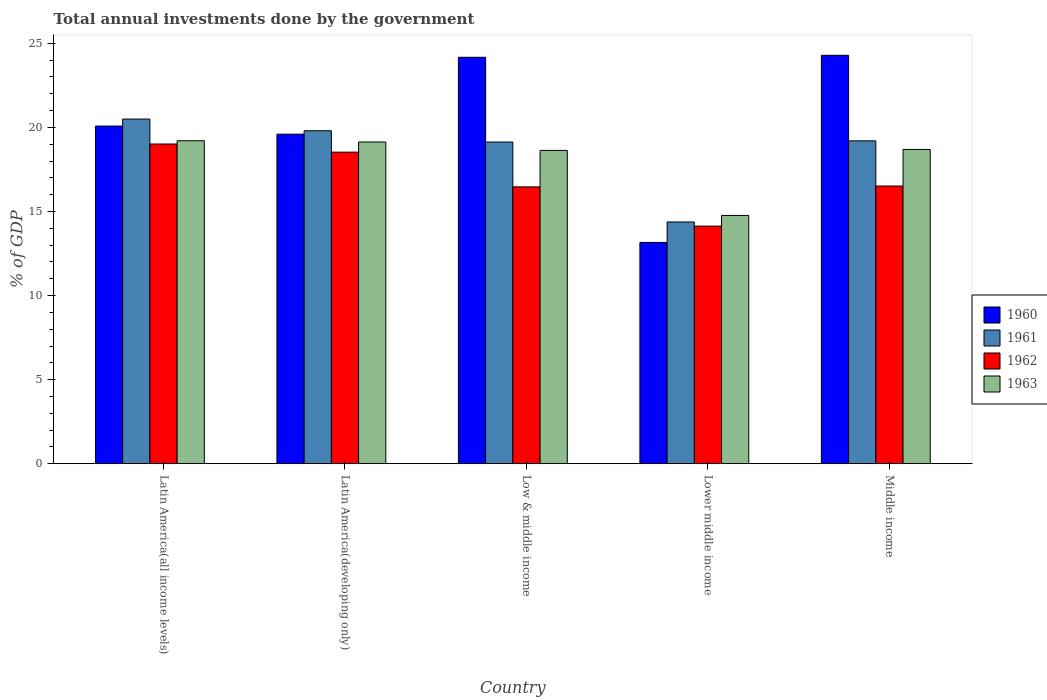Are the number of bars on each tick of the X-axis equal?
Provide a short and direct response. Yes. What is the label of the 2nd group of bars from the left?
Keep it short and to the point. Latin America(developing only). In how many cases, is the number of bars for a given country not equal to the number of legend labels?
Offer a terse response. 0. What is the total annual investments done by the government in 1961 in Lower middle income?
Ensure brevity in your answer.  14.37. Across all countries, what is the maximum total annual investments done by the government in 1962?
Offer a terse response. 19.01. Across all countries, what is the minimum total annual investments done by the government in 1961?
Offer a very short reply. 14.37. In which country was the total annual investments done by the government in 1962 maximum?
Provide a succinct answer. Latin America(all income levels). In which country was the total annual investments done by the government in 1961 minimum?
Provide a succinct answer. Lower middle income. What is the total total annual investments done by the government in 1961 in the graph?
Keep it short and to the point. 92.99. What is the difference between the total annual investments done by the government in 1962 in Lower middle income and that in Middle income?
Ensure brevity in your answer.  -2.38. What is the difference between the total annual investments done by the government in 1962 in Low & middle income and the total annual investments done by the government in 1963 in Middle income?
Your response must be concise. -2.22. What is the average total annual investments done by the government in 1963 per country?
Offer a terse response. 18.08. What is the difference between the total annual investments done by the government of/in 1961 and total annual investments done by the government of/in 1960 in Latin America(all income levels)?
Keep it short and to the point. 0.42. What is the ratio of the total annual investments done by the government in 1963 in Latin America(all income levels) to that in Middle income?
Give a very brief answer. 1.03. Is the total annual investments done by the government in 1963 in Low & middle income less than that in Middle income?
Make the answer very short. Yes. Is the difference between the total annual investments done by the government in 1961 in Latin America(all income levels) and Low & middle income greater than the difference between the total annual investments done by the government in 1960 in Latin America(all income levels) and Low & middle income?
Your response must be concise. Yes. What is the difference between the highest and the second highest total annual investments done by the government in 1961?
Your answer should be very brief. -0.6. What is the difference between the highest and the lowest total annual investments done by the government in 1962?
Ensure brevity in your answer.  4.88. In how many countries, is the total annual investments done by the government in 1961 greater than the average total annual investments done by the government in 1961 taken over all countries?
Your response must be concise. 4. Is the sum of the total annual investments done by the government in 1960 in Low & middle income and Lower middle income greater than the maximum total annual investments done by the government in 1963 across all countries?
Provide a short and direct response. Yes. Is it the case that in every country, the sum of the total annual investments done by the government in 1963 and total annual investments done by the government in 1960 is greater than the sum of total annual investments done by the government in 1961 and total annual investments done by the government in 1962?
Your answer should be compact. No. What does the 3rd bar from the left in Latin America(developing only) represents?
Provide a short and direct response. 1962. Is it the case that in every country, the sum of the total annual investments done by the government in 1963 and total annual investments done by the government in 1961 is greater than the total annual investments done by the government in 1962?
Offer a terse response. Yes. How many countries are there in the graph?
Make the answer very short. 5. Where does the legend appear in the graph?
Offer a terse response. Center right. How many legend labels are there?
Make the answer very short. 4. How are the legend labels stacked?
Keep it short and to the point. Vertical. What is the title of the graph?
Provide a succinct answer. Total annual investments done by the government. What is the label or title of the X-axis?
Ensure brevity in your answer.  Country. What is the label or title of the Y-axis?
Ensure brevity in your answer.  % of GDP. What is the % of GDP in 1960 in Latin America(all income levels)?
Make the answer very short. 20.08. What is the % of GDP of 1961 in Latin America(all income levels)?
Offer a very short reply. 20.49. What is the % of GDP of 1962 in Latin America(all income levels)?
Your answer should be compact. 19.01. What is the % of GDP of 1963 in Latin America(all income levels)?
Your answer should be compact. 19.2. What is the % of GDP in 1960 in Latin America(developing only)?
Provide a succinct answer. 19.6. What is the % of GDP in 1961 in Latin America(developing only)?
Offer a very short reply. 19.8. What is the % of GDP of 1962 in Latin America(developing only)?
Offer a very short reply. 18.53. What is the % of GDP of 1963 in Latin America(developing only)?
Your answer should be very brief. 19.13. What is the % of GDP in 1960 in Low & middle income?
Give a very brief answer. 24.17. What is the % of GDP in 1961 in Low & middle income?
Offer a very short reply. 19.13. What is the % of GDP in 1962 in Low & middle income?
Your answer should be compact. 16.46. What is the % of GDP in 1963 in Low & middle income?
Provide a succinct answer. 18.63. What is the % of GDP of 1960 in Lower middle income?
Your response must be concise. 13.16. What is the % of GDP in 1961 in Lower middle income?
Your response must be concise. 14.37. What is the % of GDP of 1962 in Lower middle income?
Offer a terse response. 14.13. What is the % of GDP of 1963 in Lower middle income?
Provide a short and direct response. 14.76. What is the % of GDP of 1960 in Middle income?
Make the answer very short. 24.28. What is the % of GDP in 1961 in Middle income?
Make the answer very short. 19.2. What is the % of GDP of 1962 in Middle income?
Make the answer very short. 16.51. What is the % of GDP of 1963 in Middle income?
Make the answer very short. 18.69. Across all countries, what is the maximum % of GDP of 1960?
Your response must be concise. 24.28. Across all countries, what is the maximum % of GDP of 1961?
Offer a very short reply. 20.49. Across all countries, what is the maximum % of GDP of 1962?
Your answer should be compact. 19.01. Across all countries, what is the maximum % of GDP of 1963?
Provide a short and direct response. 19.2. Across all countries, what is the minimum % of GDP in 1960?
Your response must be concise. 13.16. Across all countries, what is the minimum % of GDP in 1961?
Provide a succinct answer. 14.37. Across all countries, what is the minimum % of GDP of 1962?
Offer a terse response. 14.13. Across all countries, what is the minimum % of GDP in 1963?
Ensure brevity in your answer.  14.76. What is the total % of GDP in 1960 in the graph?
Provide a succinct answer. 101.28. What is the total % of GDP of 1961 in the graph?
Offer a very short reply. 92.99. What is the total % of GDP in 1962 in the graph?
Keep it short and to the point. 84.64. What is the total % of GDP of 1963 in the graph?
Make the answer very short. 90.41. What is the difference between the % of GDP of 1960 in Latin America(all income levels) and that in Latin America(developing only)?
Provide a succinct answer. 0.48. What is the difference between the % of GDP in 1961 in Latin America(all income levels) and that in Latin America(developing only)?
Offer a terse response. 0.69. What is the difference between the % of GDP of 1962 in Latin America(all income levels) and that in Latin America(developing only)?
Ensure brevity in your answer.  0.48. What is the difference between the % of GDP in 1963 in Latin America(all income levels) and that in Latin America(developing only)?
Give a very brief answer. 0.07. What is the difference between the % of GDP in 1960 in Latin America(all income levels) and that in Low & middle income?
Keep it short and to the point. -4.09. What is the difference between the % of GDP in 1961 in Latin America(all income levels) and that in Low & middle income?
Your answer should be very brief. 1.37. What is the difference between the % of GDP in 1962 in Latin America(all income levels) and that in Low & middle income?
Your response must be concise. 2.55. What is the difference between the % of GDP in 1963 in Latin America(all income levels) and that in Low & middle income?
Provide a succinct answer. 0.57. What is the difference between the % of GDP in 1960 in Latin America(all income levels) and that in Lower middle income?
Provide a short and direct response. 6.92. What is the difference between the % of GDP in 1961 in Latin America(all income levels) and that in Lower middle income?
Offer a very short reply. 6.12. What is the difference between the % of GDP in 1962 in Latin America(all income levels) and that in Lower middle income?
Make the answer very short. 4.88. What is the difference between the % of GDP of 1963 in Latin America(all income levels) and that in Lower middle income?
Your response must be concise. 4.44. What is the difference between the % of GDP in 1960 in Latin America(all income levels) and that in Middle income?
Offer a terse response. -4.21. What is the difference between the % of GDP in 1961 in Latin America(all income levels) and that in Middle income?
Provide a succinct answer. 1.3. What is the difference between the % of GDP in 1962 in Latin America(all income levels) and that in Middle income?
Provide a succinct answer. 2.5. What is the difference between the % of GDP in 1963 in Latin America(all income levels) and that in Middle income?
Provide a short and direct response. 0.52. What is the difference between the % of GDP in 1960 in Latin America(developing only) and that in Low & middle income?
Make the answer very short. -4.57. What is the difference between the % of GDP in 1961 in Latin America(developing only) and that in Low & middle income?
Keep it short and to the point. 0.67. What is the difference between the % of GDP in 1962 in Latin America(developing only) and that in Low & middle income?
Offer a very short reply. 2.07. What is the difference between the % of GDP in 1963 in Latin America(developing only) and that in Low & middle income?
Your response must be concise. 0.5. What is the difference between the % of GDP of 1960 in Latin America(developing only) and that in Lower middle income?
Your answer should be compact. 6.44. What is the difference between the % of GDP of 1961 in Latin America(developing only) and that in Lower middle income?
Provide a short and direct response. 5.42. What is the difference between the % of GDP in 1962 in Latin America(developing only) and that in Lower middle income?
Your response must be concise. 4.4. What is the difference between the % of GDP in 1963 in Latin America(developing only) and that in Lower middle income?
Ensure brevity in your answer.  4.37. What is the difference between the % of GDP in 1960 in Latin America(developing only) and that in Middle income?
Keep it short and to the point. -4.69. What is the difference between the % of GDP in 1961 in Latin America(developing only) and that in Middle income?
Your response must be concise. 0.6. What is the difference between the % of GDP of 1962 in Latin America(developing only) and that in Middle income?
Your answer should be very brief. 2.02. What is the difference between the % of GDP of 1963 in Latin America(developing only) and that in Middle income?
Give a very brief answer. 0.44. What is the difference between the % of GDP of 1960 in Low & middle income and that in Lower middle income?
Provide a short and direct response. 11.01. What is the difference between the % of GDP in 1961 in Low & middle income and that in Lower middle income?
Your answer should be compact. 4.75. What is the difference between the % of GDP of 1962 in Low & middle income and that in Lower middle income?
Provide a short and direct response. 2.33. What is the difference between the % of GDP of 1963 in Low & middle income and that in Lower middle income?
Your answer should be very brief. 3.87. What is the difference between the % of GDP of 1960 in Low & middle income and that in Middle income?
Your response must be concise. -0.12. What is the difference between the % of GDP in 1961 in Low & middle income and that in Middle income?
Offer a very short reply. -0.07. What is the difference between the % of GDP of 1962 in Low & middle income and that in Middle income?
Your response must be concise. -0.05. What is the difference between the % of GDP in 1963 in Low & middle income and that in Middle income?
Your answer should be compact. -0.06. What is the difference between the % of GDP in 1960 in Lower middle income and that in Middle income?
Provide a succinct answer. -11.13. What is the difference between the % of GDP in 1961 in Lower middle income and that in Middle income?
Ensure brevity in your answer.  -4.82. What is the difference between the % of GDP in 1962 in Lower middle income and that in Middle income?
Offer a terse response. -2.38. What is the difference between the % of GDP of 1963 in Lower middle income and that in Middle income?
Your response must be concise. -3.92. What is the difference between the % of GDP in 1960 in Latin America(all income levels) and the % of GDP in 1961 in Latin America(developing only)?
Offer a very short reply. 0.28. What is the difference between the % of GDP in 1960 in Latin America(all income levels) and the % of GDP in 1962 in Latin America(developing only)?
Offer a terse response. 1.55. What is the difference between the % of GDP of 1960 in Latin America(all income levels) and the % of GDP of 1963 in Latin America(developing only)?
Provide a short and direct response. 0.95. What is the difference between the % of GDP of 1961 in Latin America(all income levels) and the % of GDP of 1962 in Latin America(developing only)?
Provide a succinct answer. 1.97. What is the difference between the % of GDP in 1961 in Latin America(all income levels) and the % of GDP in 1963 in Latin America(developing only)?
Provide a succinct answer. 1.36. What is the difference between the % of GDP in 1962 in Latin America(all income levels) and the % of GDP in 1963 in Latin America(developing only)?
Offer a very short reply. -0.12. What is the difference between the % of GDP of 1960 in Latin America(all income levels) and the % of GDP of 1961 in Low & middle income?
Your answer should be very brief. 0.95. What is the difference between the % of GDP in 1960 in Latin America(all income levels) and the % of GDP in 1962 in Low & middle income?
Provide a succinct answer. 3.62. What is the difference between the % of GDP of 1960 in Latin America(all income levels) and the % of GDP of 1963 in Low & middle income?
Offer a very short reply. 1.45. What is the difference between the % of GDP in 1961 in Latin America(all income levels) and the % of GDP in 1962 in Low & middle income?
Provide a succinct answer. 4.03. What is the difference between the % of GDP of 1961 in Latin America(all income levels) and the % of GDP of 1963 in Low & middle income?
Make the answer very short. 1.86. What is the difference between the % of GDP of 1962 in Latin America(all income levels) and the % of GDP of 1963 in Low & middle income?
Your answer should be compact. 0.38. What is the difference between the % of GDP of 1960 in Latin America(all income levels) and the % of GDP of 1961 in Lower middle income?
Ensure brevity in your answer.  5.7. What is the difference between the % of GDP in 1960 in Latin America(all income levels) and the % of GDP in 1962 in Lower middle income?
Make the answer very short. 5.95. What is the difference between the % of GDP in 1960 in Latin America(all income levels) and the % of GDP in 1963 in Lower middle income?
Keep it short and to the point. 5.31. What is the difference between the % of GDP of 1961 in Latin America(all income levels) and the % of GDP of 1962 in Lower middle income?
Provide a short and direct response. 6.36. What is the difference between the % of GDP of 1961 in Latin America(all income levels) and the % of GDP of 1963 in Lower middle income?
Your answer should be very brief. 5.73. What is the difference between the % of GDP in 1962 in Latin America(all income levels) and the % of GDP in 1963 in Lower middle income?
Your answer should be very brief. 4.25. What is the difference between the % of GDP in 1960 in Latin America(all income levels) and the % of GDP in 1961 in Middle income?
Give a very brief answer. 0.88. What is the difference between the % of GDP in 1960 in Latin America(all income levels) and the % of GDP in 1962 in Middle income?
Provide a succinct answer. 3.57. What is the difference between the % of GDP of 1960 in Latin America(all income levels) and the % of GDP of 1963 in Middle income?
Make the answer very short. 1.39. What is the difference between the % of GDP of 1961 in Latin America(all income levels) and the % of GDP of 1962 in Middle income?
Offer a very short reply. 3.98. What is the difference between the % of GDP of 1961 in Latin America(all income levels) and the % of GDP of 1963 in Middle income?
Your answer should be compact. 1.81. What is the difference between the % of GDP of 1962 in Latin America(all income levels) and the % of GDP of 1963 in Middle income?
Offer a very short reply. 0.32. What is the difference between the % of GDP in 1960 in Latin America(developing only) and the % of GDP in 1961 in Low & middle income?
Your answer should be compact. 0.47. What is the difference between the % of GDP of 1960 in Latin America(developing only) and the % of GDP of 1962 in Low & middle income?
Provide a short and direct response. 3.13. What is the difference between the % of GDP of 1960 in Latin America(developing only) and the % of GDP of 1963 in Low & middle income?
Keep it short and to the point. 0.97. What is the difference between the % of GDP of 1961 in Latin America(developing only) and the % of GDP of 1962 in Low & middle income?
Keep it short and to the point. 3.34. What is the difference between the % of GDP in 1961 in Latin America(developing only) and the % of GDP in 1963 in Low & middle income?
Offer a terse response. 1.17. What is the difference between the % of GDP in 1962 in Latin America(developing only) and the % of GDP in 1963 in Low & middle income?
Offer a very short reply. -0.1. What is the difference between the % of GDP of 1960 in Latin America(developing only) and the % of GDP of 1961 in Lower middle income?
Offer a terse response. 5.22. What is the difference between the % of GDP of 1960 in Latin America(developing only) and the % of GDP of 1962 in Lower middle income?
Your response must be concise. 5.47. What is the difference between the % of GDP of 1960 in Latin America(developing only) and the % of GDP of 1963 in Lower middle income?
Your answer should be very brief. 4.83. What is the difference between the % of GDP in 1961 in Latin America(developing only) and the % of GDP in 1962 in Lower middle income?
Provide a succinct answer. 5.67. What is the difference between the % of GDP in 1961 in Latin America(developing only) and the % of GDP in 1963 in Lower middle income?
Provide a succinct answer. 5.04. What is the difference between the % of GDP of 1962 in Latin America(developing only) and the % of GDP of 1963 in Lower middle income?
Ensure brevity in your answer.  3.76. What is the difference between the % of GDP in 1960 in Latin America(developing only) and the % of GDP in 1961 in Middle income?
Give a very brief answer. 0.4. What is the difference between the % of GDP of 1960 in Latin America(developing only) and the % of GDP of 1962 in Middle income?
Your answer should be very brief. 3.08. What is the difference between the % of GDP in 1960 in Latin America(developing only) and the % of GDP in 1963 in Middle income?
Provide a short and direct response. 0.91. What is the difference between the % of GDP in 1961 in Latin America(developing only) and the % of GDP in 1962 in Middle income?
Make the answer very short. 3.29. What is the difference between the % of GDP of 1961 in Latin America(developing only) and the % of GDP of 1963 in Middle income?
Offer a very short reply. 1.11. What is the difference between the % of GDP in 1962 in Latin America(developing only) and the % of GDP in 1963 in Middle income?
Offer a terse response. -0.16. What is the difference between the % of GDP in 1960 in Low & middle income and the % of GDP in 1961 in Lower middle income?
Provide a succinct answer. 9.79. What is the difference between the % of GDP of 1960 in Low & middle income and the % of GDP of 1962 in Lower middle income?
Ensure brevity in your answer.  10.04. What is the difference between the % of GDP in 1960 in Low & middle income and the % of GDP in 1963 in Lower middle income?
Your answer should be compact. 9.4. What is the difference between the % of GDP of 1961 in Low & middle income and the % of GDP of 1962 in Lower middle income?
Offer a very short reply. 5. What is the difference between the % of GDP of 1961 in Low & middle income and the % of GDP of 1963 in Lower middle income?
Keep it short and to the point. 4.36. What is the difference between the % of GDP of 1962 in Low & middle income and the % of GDP of 1963 in Lower middle income?
Keep it short and to the point. 1.7. What is the difference between the % of GDP in 1960 in Low & middle income and the % of GDP in 1961 in Middle income?
Keep it short and to the point. 4.97. What is the difference between the % of GDP in 1960 in Low & middle income and the % of GDP in 1962 in Middle income?
Make the answer very short. 7.66. What is the difference between the % of GDP in 1960 in Low & middle income and the % of GDP in 1963 in Middle income?
Your answer should be compact. 5.48. What is the difference between the % of GDP in 1961 in Low & middle income and the % of GDP in 1962 in Middle income?
Provide a short and direct response. 2.62. What is the difference between the % of GDP in 1961 in Low & middle income and the % of GDP in 1963 in Middle income?
Your answer should be compact. 0.44. What is the difference between the % of GDP of 1962 in Low & middle income and the % of GDP of 1963 in Middle income?
Give a very brief answer. -2.22. What is the difference between the % of GDP of 1960 in Lower middle income and the % of GDP of 1961 in Middle income?
Offer a terse response. -6.04. What is the difference between the % of GDP in 1960 in Lower middle income and the % of GDP in 1962 in Middle income?
Keep it short and to the point. -3.35. What is the difference between the % of GDP in 1960 in Lower middle income and the % of GDP in 1963 in Middle income?
Your answer should be compact. -5.53. What is the difference between the % of GDP in 1961 in Lower middle income and the % of GDP in 1962 in Middle income?
Your answer should be compact. -2.14. What is the difference between the % of GDP of 1961 in Lower middle income and the % of GDP of 1963 in Middle income?
Offer a terse response. -4.31. What is the difference between the % of GDP in 1962 in Lower middle income and the % of GDP in 1963 in Middle income?
Offer a terse response. -4.56. What is the average % of GDP of 1960 per country?
Your answer should be compact. 20.26. What is the average % of GDP of 1961 per country?
Your answer should be very brief. 18.6. What is the average % of GDP in 1962 per country?
Offer a terse response. 16.93. What is the average % of GDP of 1963 per country?
Ensure brevity in your answer.  18.08. What is the difference between the % of GDP of 1960 and % of GDP of 1961 in Latin America(all income levels)?
Your answer should be very brief. -0.41. What is the difference between the % of GDP of 1960 and % of GDP of 1962 in Latin America(all income levels)?
Make the answer very short. 1.07. What is the difference between the % of GDP of 1960 and % of GDP of 1963 in Latin America(all income levels)?
Provide a succinct answer. 0.87. What is the difference between the % of GDP in 1961 and % of GDP in 1962 in Latin America(all income levels)?
Your response must be concise. 1.48. What is the difference between the % of GDP in 1961 and % of GDP in 1963 in Latin America(all income levels)?
Provide a succinct answer. 1.29. What is the difference between the % of GDP of 1962 and % of GDP of 1963 in Latin America(all income levels)?
Keep it short and to the point. -0.19. What is the difference between the % of GDP of 1960 and % of GDP of 1961 in Latin America(developing only)?
Your response must be concise. -0.2. What is the difference between the % of GDP in 1960 and % of GDP in 1962 in Latin America(developing only)?
Your answer should be very brief. 1.07. What is the difference between the % of GDP in 1960 and % of GDP in 1963 in Latin America(developing only)?
Your answer should be very brief. 0.46. What is the difference between the % of GDP in 1961 and % of GDP in 1962 in Latin America(developing only)?
Ensure brevity in your answer.  1.27. What is the difference between the % of GDP of 1961 and % of GDP of 1963 in Latin America(developing only)?
Keep it short and to the point. 0.67. What is the difference between the % of GDP of 1962 and % of GDP of 1963 in Latin America(developing only)?
Give a very brief answer. -0.6. What is the difference between the % of GDP of 1960 and % of GDP of 1961 in Low & middle income?
Keep it short and to the point. 5.04. What is the difference between the % of GDP of 1960 and % of GDP of 1962 in Low & middle income?
Make the answer very short. 7.71. What is the difference between the % of GDP of 1960 and % of GDP of 1963 in Low & middle income?
Your answer should be very brief. 5.54. What is the difference between the % of GDP of 1961 and % of GDP of 1962 in Low & middle income?
Give a very brief answer. 2.67. What is the difference between the % of GDP of 1961 and % of GDP of 1963 in Low & middle income?
Your response must be concise. 0.5. What is the difference between the % of GDP of 1962 and % of GDP of 1963 in Low & middle income?
Your response must be concise. -2.17. What is the difference between the % of GDP in 1960 and % of GDP in 1961 in Lower middle income?
Provide a succinct answer. -1.22. What is the difference between the % of GDP of 1960 and % of GDP of 1962 in Lower middle income?
Ensure brevity in your answer.  -0.97. What is the difference between the % of GDP in 1960 and % of GDP in 1963 in Lower middle income?
Make the answer very short. -1.6. What is the difference between the % of GDP of 1961 and % of GDP of 1962 in Lower middle income?
Offer a very short reply. 0.25. What is the difference between the % of GDP of 1961 and % of GDP of 1963 in Lower middle income?
Provide a short and direct response. -0.39. What is the difference between the % of GDP of 1962 and % of GDP of 1963 in Lower middle income?
Offer a terse response. -0.64. What is the difference between the % of GDP in 1960 and % of GDP in 1961 in Middle income?
Ensure brevity in your answer.  5.09. What is the difference between the % of GDP in 1960 and % of GDP in 1962 in Middle income?
Offer a very short reply. 7.77. What is the difference between the % of GDP in 1960 and % of GDP in 1963 in Middle income?
Offer a very short reply. 5.6. What is the difference between the % of GDP in 1961 and % of GDP in 1962 in Middle income?
Offer a terse response. 2.69. What is the difference between the % of GDP in 1961 and % of GDP in 1963 in Middle income?
Provide a short and direct response. 0.51. What is the difference between the % of GDP of 1962 and % of GDP of 1963 in Middle income?
Offer a very short reply. -2.18. What is the ratio of the % of GDP in 1960 in Latin America(all income levels) to that in Latin America(developing only)?
Make the answer very short. 1.02. What is the ratio of the % of GDP in 1961 in Latin America(all income levels) to that in Latin America(developing only)?
Offer a very short reply. 1.03. What is the ratio of the % of GDP in 1962 in Latin America(all income levels) to that in Latin America(developing only)?
Provide a short and direct response. 1.03. What is the ratio of the % of GDP of 1960 in Latin America(all income levels) to that in Low & middle income?
Your answer should be very brief. 0.83. What is the ratio of the % of GDP in 1961 in Latin America(all income levels) to that in Low & middle income?
Provide a short and direct response. 1.07. What is the ratio of the % of GDP in 1962 in Latin America(all income levels) to that in Low & middle income?
Your answer should be compact. 1.15. What is the ratio of the % of GDP of 1963 in Latin America(all income levels) to that in Low & middle income?
Offer a terse response. 1.03. What is the ratio of the % of GDP of 1960 in Latin America(all income levels) to that in Lower middle income?
Keep it short and to the point. 1.53. What is the ratio of the % of GDP of 1961 in Latin America(all income levels) to that in Lower middle income?
Offer a terse response. 1.43. What is the ratio of the % of GDP of 1962 in Latin America(all income levels) to that in Lower middle income?
Your answer should be very brief. 1.35. What is the ratio of the % of GDP of 1963 in Latin America(all income levels) to that in Lower middle income?
Give a very brief answer. 1.3. What is the ratio of the % of GDP of 1960 in Latin America(all income levels) to that in Middle income?
Offer a terse response. 0.83. What is the ratio of the % of GDP in 1961 in Latin America(all income levels) to that in Middle income?
Give a very brief answer. 1.07. What is the ratio of the % of GDP of 1962 in Latin America(all income levels) to that in Middle income?
Provide a succinct answer. 1.15. What is the ratio of the % of GDP in 1963 in Latin America(all income levels) to that in Middle income?
Ensure brevity in your answer.  1.03. What is the ratio of the % of GDP of 1960 in Latin America(developing only) to that in Low & middle income?
Your answer should be very brief. 0.81. What is the ratio of the % of GDP in 1961 in Latin America(developing only) to that in Low & middle income?
Make the answer very short. 1.04. What is the ratio of the % of GDP of 1962 in Latin America(developing only) to that in Low & middle income?
Ensure brevity in your answer.  1.13. What is the ratio of the % of GDP in 1963 in Latin America(developing only) to that in Low & middle income?
Make the answer very short. 1.03. What is the ratio of the % of GDP in 1960 in Latin America(developing only) to that in Lower middle income?
Your answer should be very brief. 1.49. What is the ratio of the % of GDP of 1961 in Latin America(developing only) to that in Lower middle income?
Ensure brevity in your answer.  1.38. What is the ratio of the % of GDP in 1962 in Latin America(developing only) to that in Lower middle income?
Your answer should be very brief. 1.31. What is the ratio of the % of GDP of 1963 in Latin America(developing only) to that in Lower middle income?
Make the answer very short. 1.3. What is the ratio of the % of GDP of 1960 in Latin America(developing only) to that in Middle income?
Keep it short and to the point. 0.81. What is the ratio of the % of GDP of 1961 in Latin America(developing only) to that in Middle income?
Make the answer very short. 1.03. What is the ratio of the % of GDP of 1962 in Latin America(developing only) to that in Middle income?
Offer a very short reply. 1.12. What is the ratio of the % of GDP in 1963 in Latin America(developing only) to that in Middle income?
Provide a short and direct response. 1.02. What is the ratio of the % of GDP of 1960 in Low & middle income to that in Lower middle income?
Your response must be concise. 1.84. What is the ratio of the % of GDP in 1961 in Low & middle income to that in Lower middle income?
Provide a succinct answer. 1.33. What is the ratio of the % of GDP in 1962 in Low & middle income to that in Lower middle income?
Ensure brevity in your answer.  1.17. What is the ratio of the % of GDP in 1963 in Low & middle income to that in Lower middle income?
Provide a succinct answer. 1.26. What is the ratio of the % of GDP of 1963 in Low & middle income to that in Middle income?
Keep it short and to the point. 1. What is the ratio of the % of GDP of 1960 in Lower middle income to that in Middle income?
Provide a succinct answer. 0.54. What is the ratio of the % of GDP in 1961 in Lower middle income to that in Middle income?
Offer a very short reply. 0.75. What is the ratio of the % of GDP of 1962 in Lower middle income to that in Middle income?
Provide a short and direct response. 0.86. What is the ratio of the % of GDP of 1963 in Lower middle income to that in Middle income?
Make the answer very short. 0.79. What is the difference between the highest and the second highest % of GDP of 1960?
Your answer should be compact. 0.12. What is the difference between the highest and the second highest % of GDP of 1961?
Ensure brevity in your answer.  0.69. What is the difference between the highest and the second highest % of GDP in 1962?
Keep it short and to the point. 0.48. What is the difference between the highest and the second highest % of GDP of 1963?
Your response must be concise. 0.07. What is the difference between the highest and the lowest % of GDP in 1960?
Offer a very short reply. 11.13. What is the difference between the highest and the lowest % of GDP in 1961?
Your answer should be compact. 6.12. What is the difference between the highest and the lowest % of GDP of 1962?
Your answer should be very brief. 4.88. What is the difference between the highest and the lowest % of GDP of 1963?
Provide a short and direct response. 4.44. 